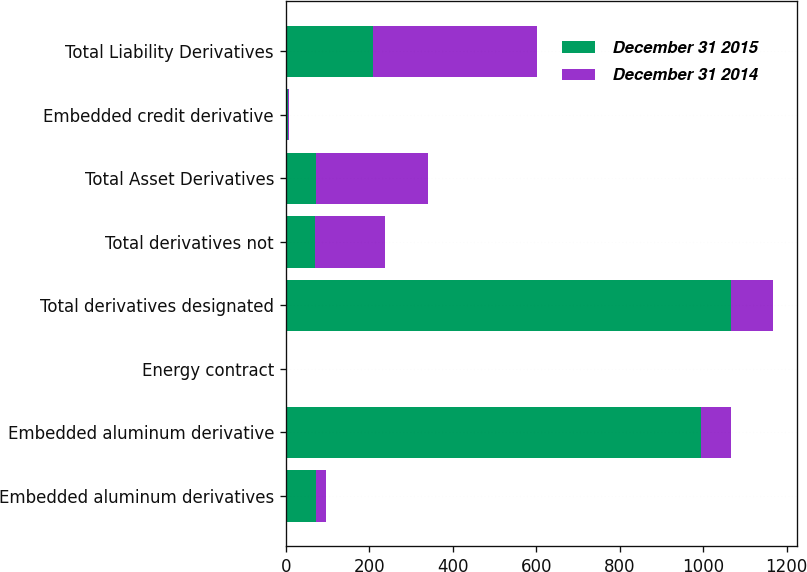Convert chart. <chart><loc_0><loc_0><loc_500><loc_500><stacked_bar_chart><ecel><fcel>Embedded aluminum derivatives<fcel>Embedded aluminum derivative<fcel>Energy contract<fcel>Total derivatives designated<fcel>Total derivatives not<fcel>Total Asset Derivatives<fcel>Embedded credit derivative<fcel>Total Liability Derivatives<nl><fcel>December 31 2015<fcel>72<fcel>994<fcel>2<fcel>1068<fcel>69<fcel>73<fcel>6<fcel>208<nl><fcel>December 31 2014<fcel>24<fcel>73<fcel>2<fcel>99<fcel>169<fcel>268<fcel>2<fcel>394<nl></chart> 